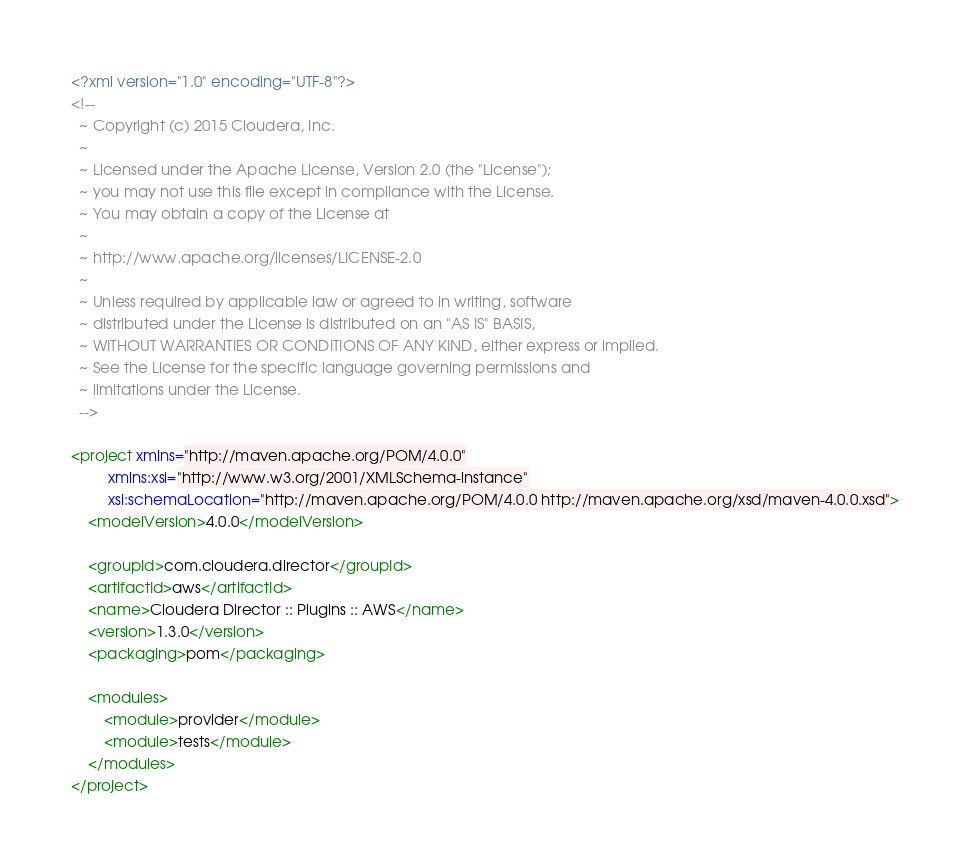Convert code to text. <code><loc_0><loc_0><loc_500><loc_500><_XML_><?xml version="1.0" encoding="UTF-8"?>
<!--
  ~ Copyright (c) 2015 Cloudera, Inc.
  ~
  ~ Licensed under the Apache License, Version 2.0 (the "License");
  ~ you may not use this file except in compliance with the License.
  ~ You may obtain a copy of the License at
  ~
  ~ http://www.apache.org/licenses/LICENSE-2.0
  ~
  ~ Unless required by applicable law or agreed to in writing, software
  ~ distributed under the License is distributed on an "AS IS" BASIS,
  ~ WITHOUT WARRANTIES OR CONDITIONS OF ANY KIND, either express or implied.
  ~ See the License for the specific language governing permissions and
  ~ limitations under the License.
  -->

<project xmlns="http://maven.apache.org/POM/4.0.0"
         xmlns:xsi="http://www.w3.org/2001/XMLSchema-instance"
         xsi:schemaLocation="http://maven.apache.org/POM/4.0.0 http://maven.apache.org/xsd/maven-4.0.0.xsd">
    <modelVersion>4.0.0</modelVersion>

    <groupId>com.cloudera.director</groupId>
    <artifactId>aws</artifactId>
    <name>Cloudera Director :: Plugins :: AWS</name>
    <version>1.3.0</version>
    <packaging>pom</packaging>

    <modules>
        <module>provider</module>
        <module>tests</module>
    </modules>
</project>
</code> 